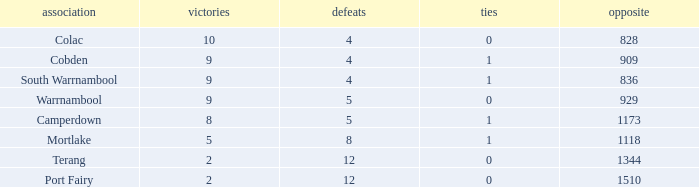What is the total number of Against values for clubs with more than 2 wins, 5 losses, and 0 draws? 0.0. 